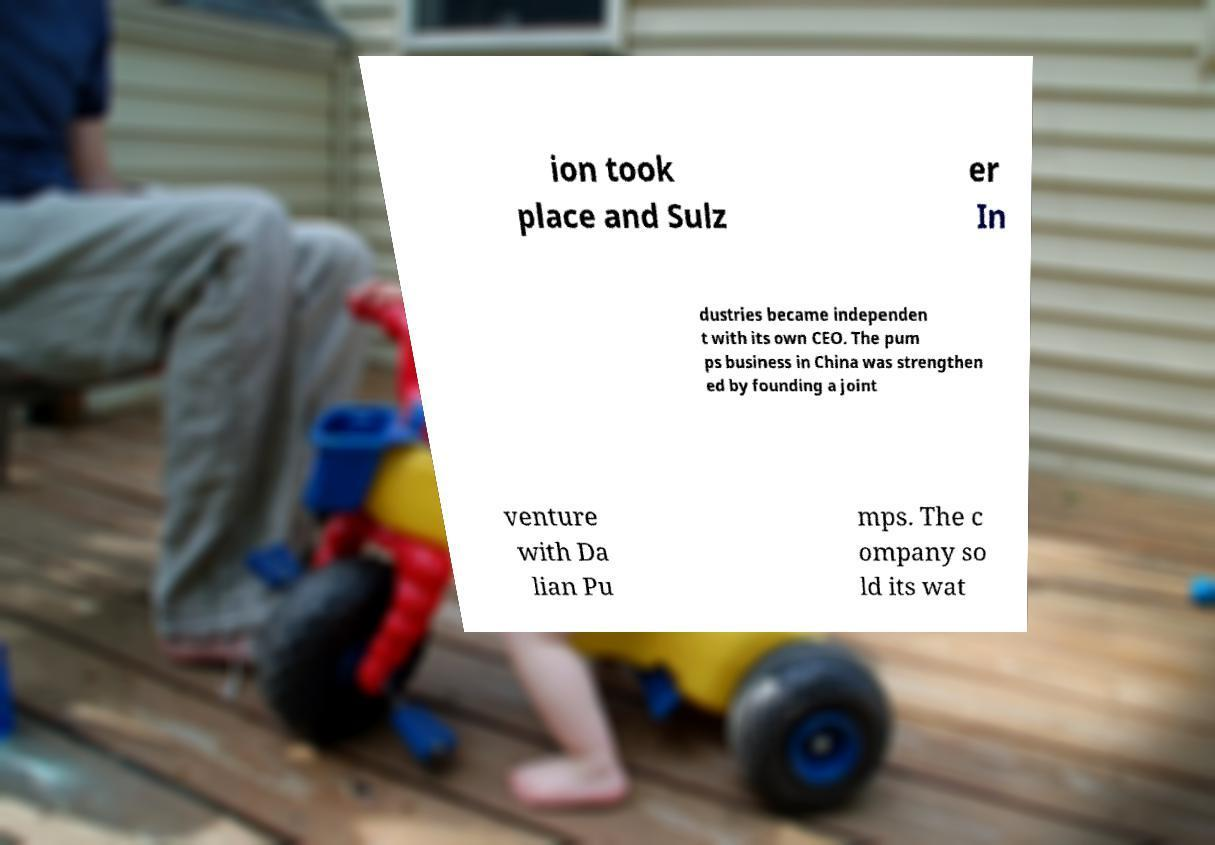There's text embedded in this image that I need extracted. Can you transcribe it verbatim? ion took place and Sulz er In dustries became independen t with its own CEO. The pum ps business in China was strengthen ed by founding a joint venture with Da lian Pu mps. The c ompany so ld its wat 